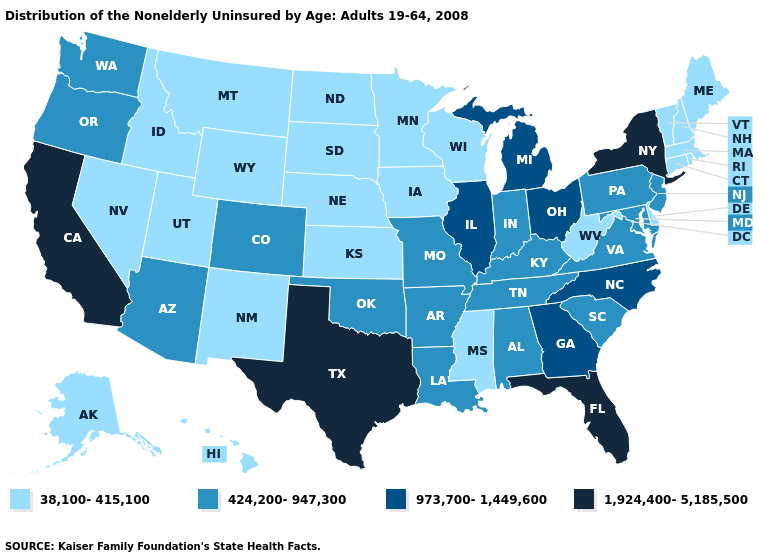What is the highest value in the USA?
Give a very brief answer. 1,924,400-5,185,500. Which states have the lowest value in the West?
Answer briefly. Alaska, Hawaii, Idaho, Montana, Nevada, New Mexico, Utah, Wyoming. What is the value of Texas?
Give a very brief answer. 1,924,400-5,185,500. Name the states that have a value in the range 973,700-1,449,600?
Quick response, please. Georgia, Illinois, Michigan, North Carolina, Ohio. What is the lowest value in states that border Iowa?
Short answer required. 38,100-415,100. What is the value of Delaware?
Keep it brief. 38,100-415,100. What is the value of Oregon?
Keep it brief. 424,200-947,300. Does Michigan have the lowest value in the MidWest?
Short answer required. No. What is the value of Idaho?
Keep it brief. 38,100-415,100. Among the states that border South Dakota , which have the lowest value?
Be succinct. Iowa, Minnesota, Montana, Nebraska, North Dakota, Wyoming. How many symbols are there in the legend?
Keep it brief. 4. How many symbols are there in the legend?
Concise answer only. 4. Among the states that border Vermont , which have the lowest value?
Concise answer only. Massachusetts, New Hampshire. Which states have the highest value in the USA?
Keep it brief. California, Florida, New York, Texas. Name the states that have a value in the range 424,200-947,300?
Be succinct. Alabama, Arizona, Arkansas, Colorado, Indiana, Kentucky, Louisiana, Maryland, Missouri, New Jersey, Oklahoma, Oregon, Pennsylvania, South Carolina, Tennessee, Virginia, Washington. 